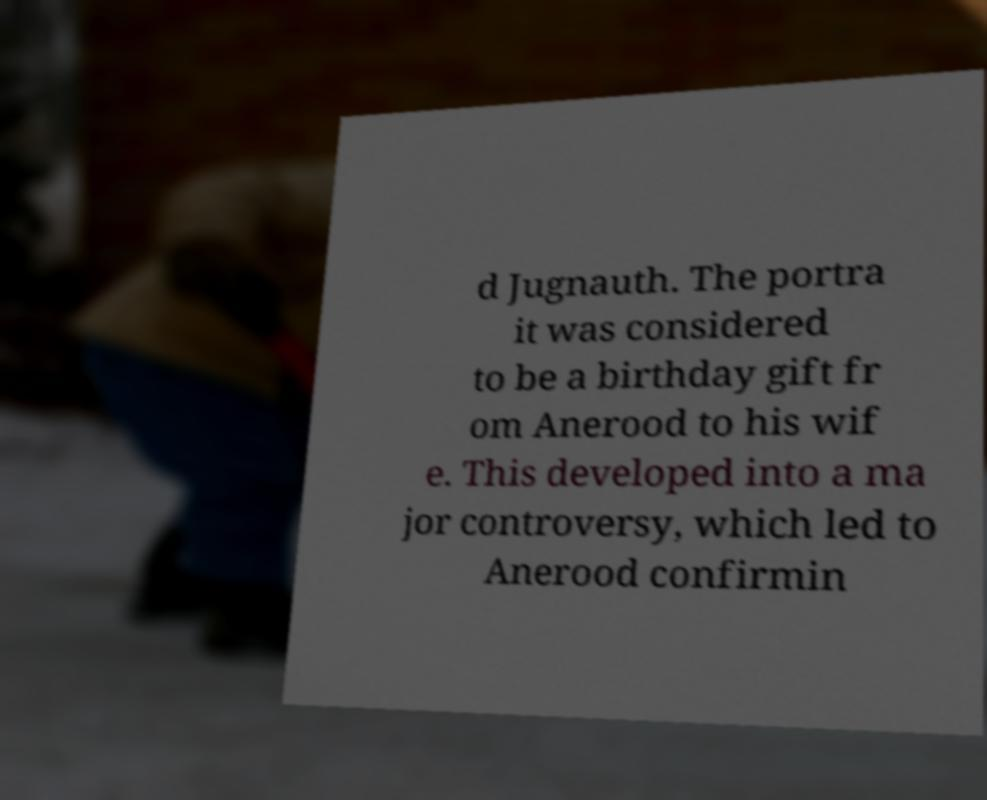There's text embedded in this image that I need extracted. Can you transcribe it verbatim? d Jugnauth. The portra it was considered to be a birthday gift fr om Anerood to his wif e. This developed into a ma jor controversy, which led to Anerood confirmin 